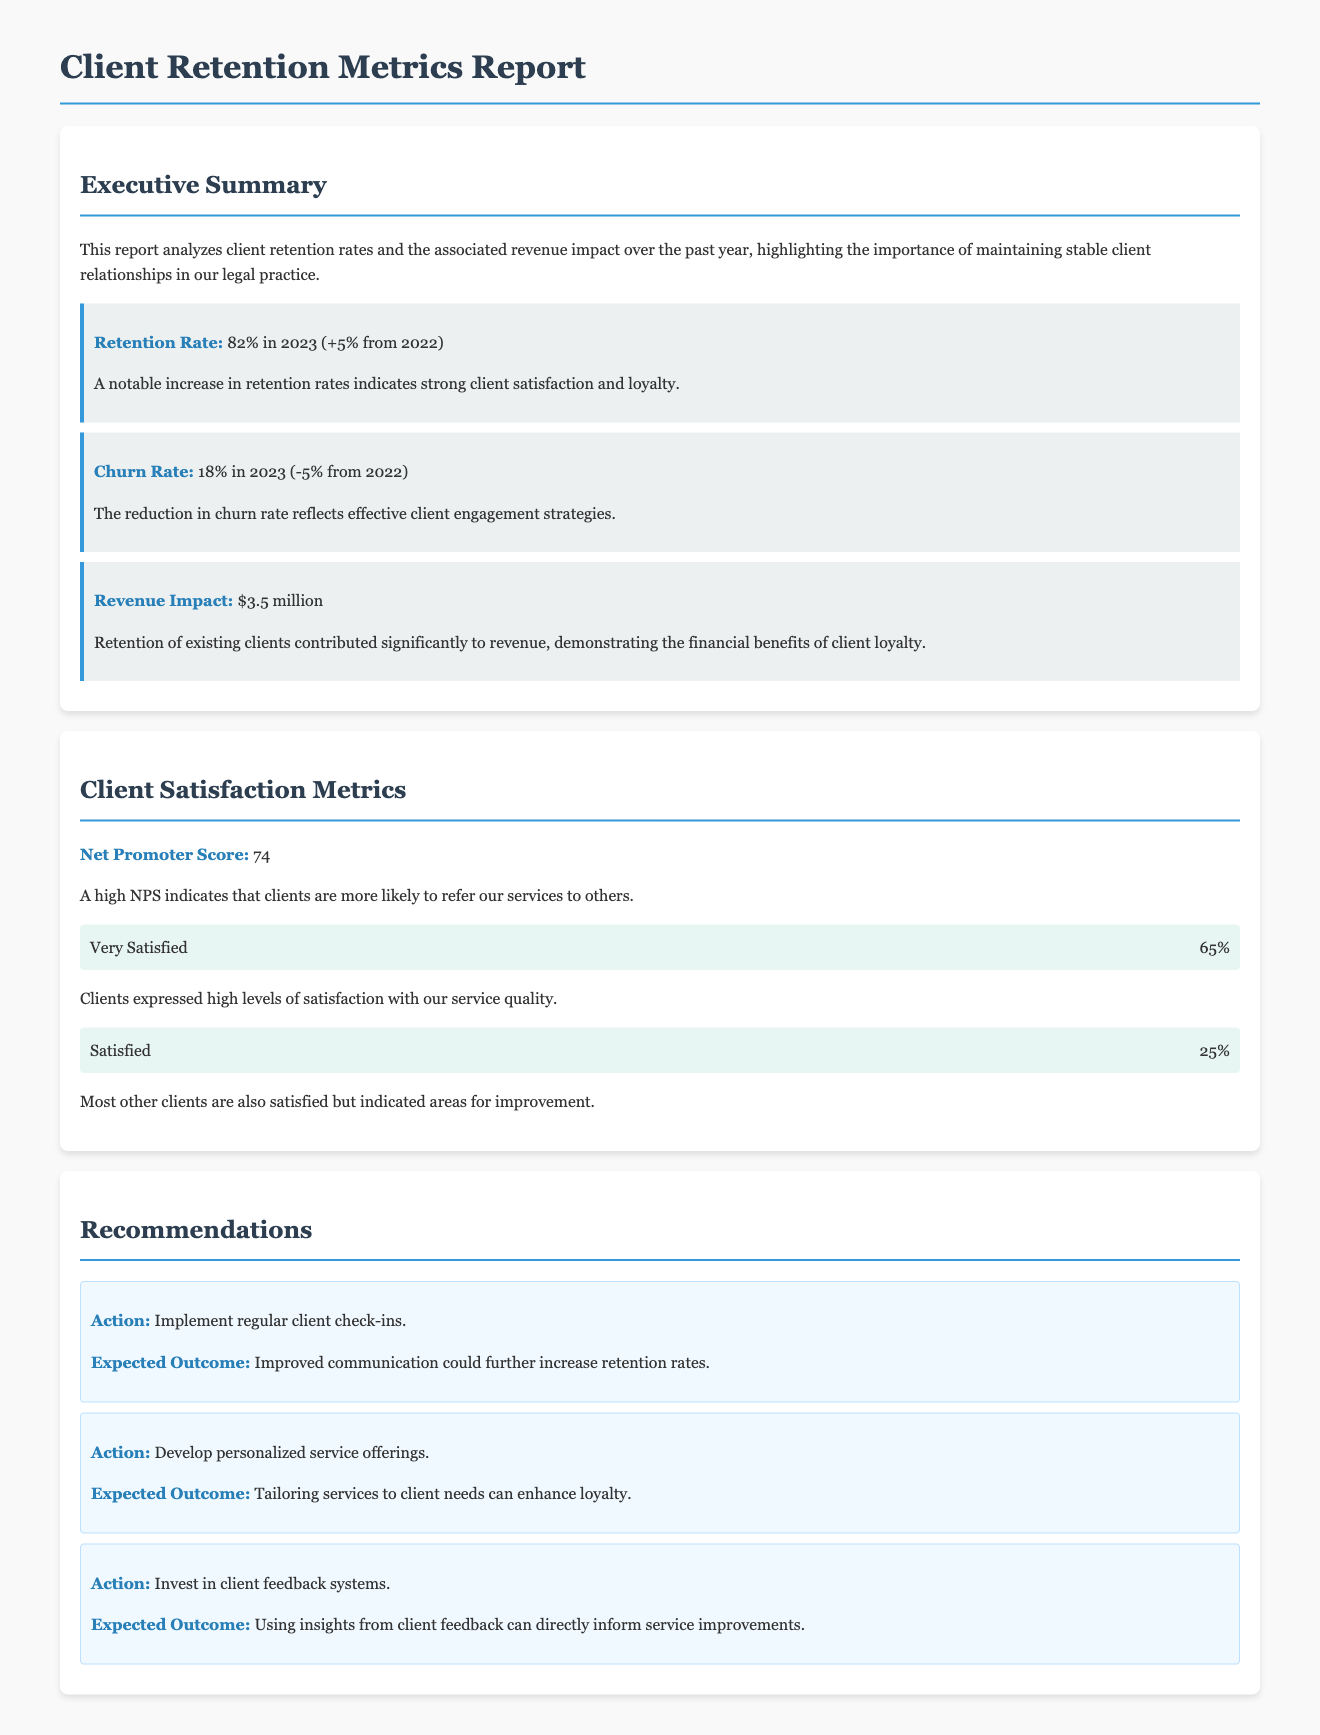What was the retention rate in 2023? The retention rate for 2023 is explicitly stated in the report section, which shows a clear increase from the previous year.
Answer: 82% What was the churn rate in 2023? The report specifies the churn rate for 2023 and indicates a change compared to the previous year.
Answer: 18% How much revenue did client retention contribute in 2023? The revenue impact from retention is highlighted in the executive summary of the report.
Answer: $3.5 million What is the Net Promoter Score for the clients? The Net Promoter Score is given as a definitive number in the Client Satisfaction Metrics section.
Answer: 74 What percentage of clients were very satisfied? The percentage of clients who were categorized as very satisfied is mentioned in the satisfaction metrics.
Answer: 65% What actions are recommended to improve client retention? The recommendations discuss various actions to enhance retention, focusing on specific improvements.
Answer: Regular client check-ins, personalized service offerings, invest in client feedback systems Which metric indicates the likelihood of client referrals? The Net Promoter Score serves as a critical metric that conveys clients' propensity to recommend services.
Answer: Net Promoter Score 